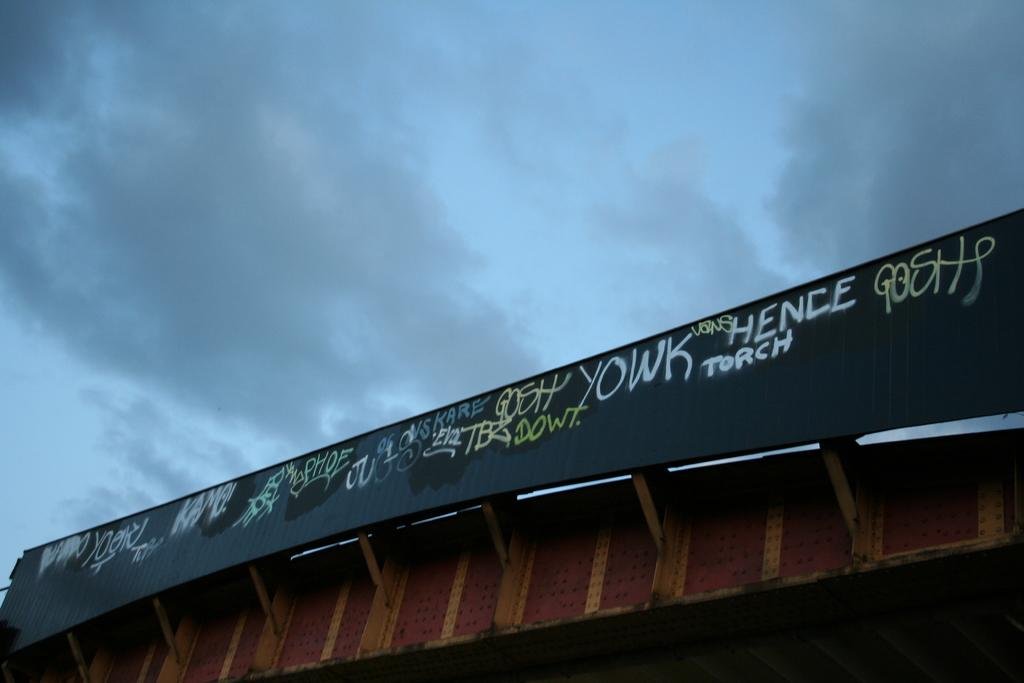<image>
Provide a brief description of the given image. Some graffiti reads the words "YOWK", TORCH", and "HENCE." 